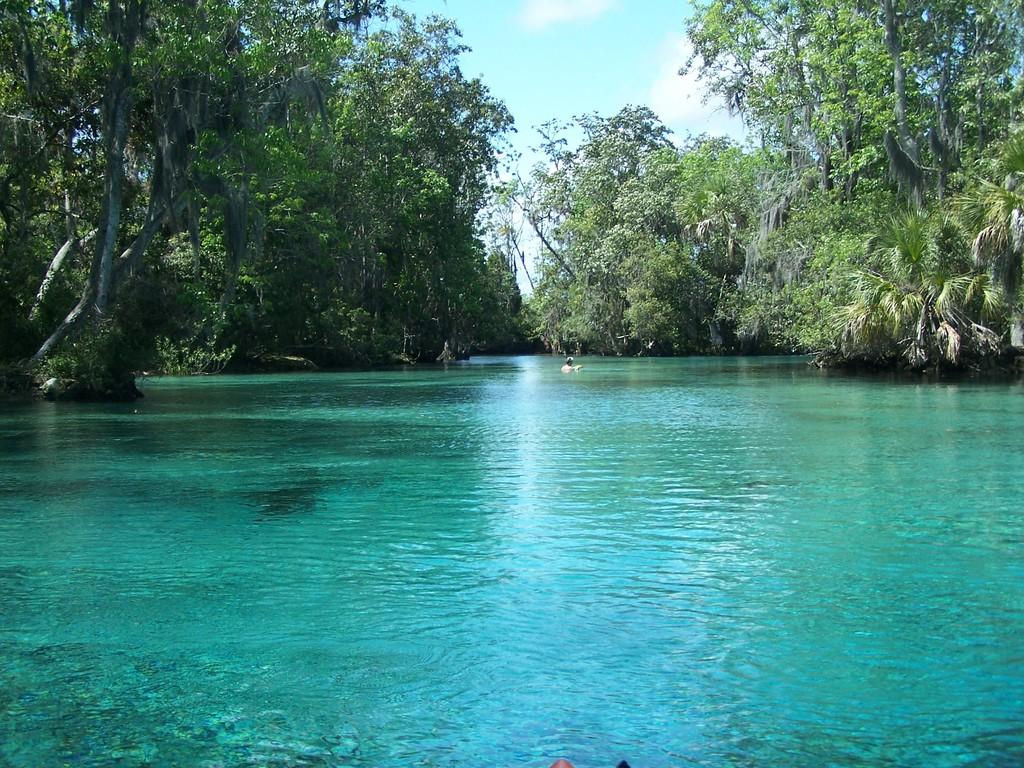What is the main subject of the image? There is a person in the water in the center of the image. What can be seen in the background of the image? There are trees and water visible in the background of the image. What is visible at the top of the image? The sky is visible at the top of the image. What type of branch is the person holding in the image? There is no branch present in the image. What kind of apparel is the person wearing in the image? The provided facts do not mention the person's apparel. Can you see a pan in the image? There is no pan present in the image. 